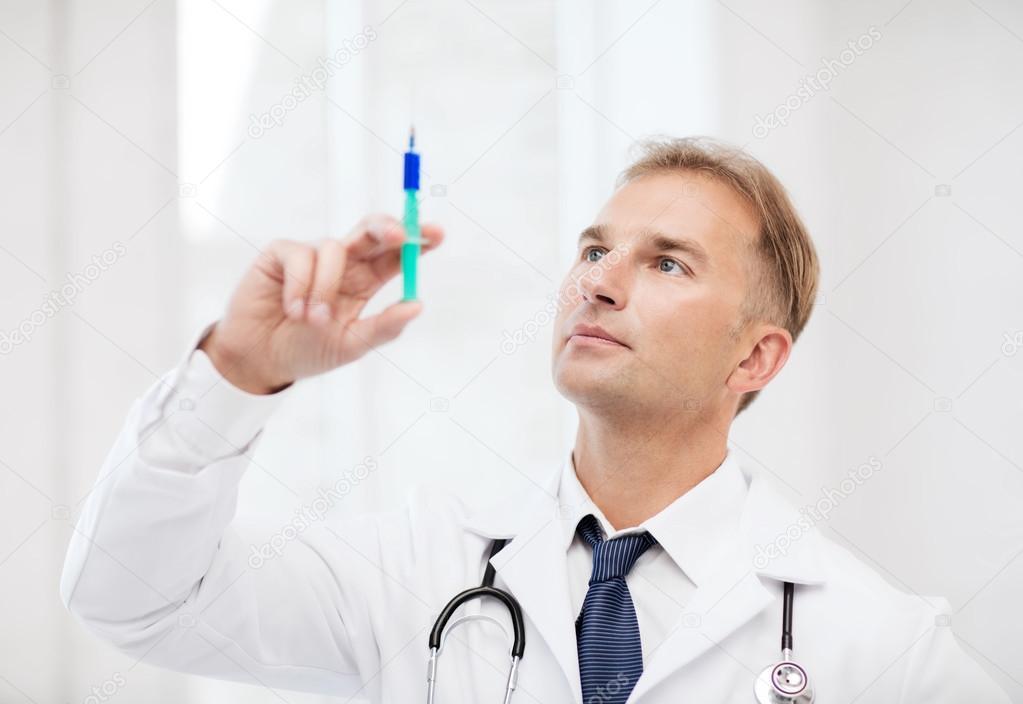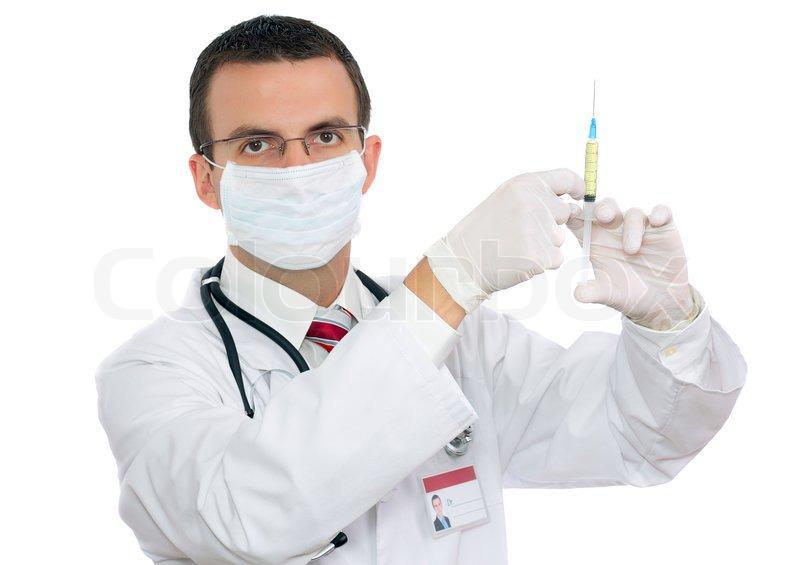The first image is the image on the left, the second image is the image on the right. Assess this claim about the two images: "There is a woman visible in one of the images.". Correct or not? Answer yes or no. No. The first image is the image on the left, the second image is the image on the right. Given the left and right images, does the statement "Two doctors are looking at syringes." hold true? Answer yes or no. No. 